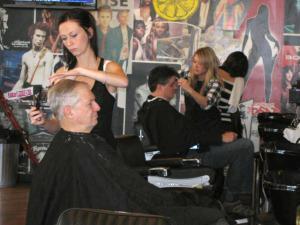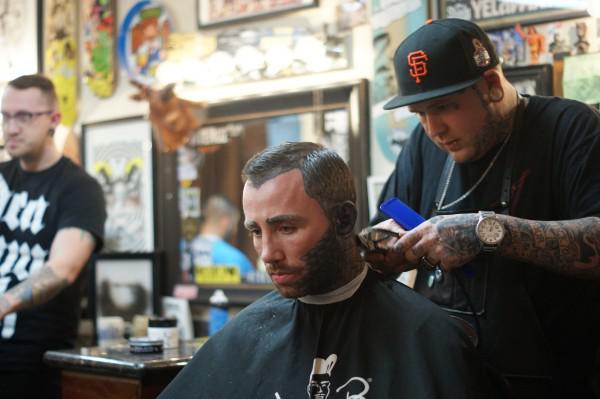The first image is the image on the left, the second image is the image on the right. For the images shown, is this caption "IN at least one image there are two men in a row getting their cut." true? Answer yes or no. Yes. The first image is the image on the left, the second image is the image on the right. Examine the images to the left and right. Is the description "Someone is wearing a hat in both images." accurate? Answer yes or no. No. 